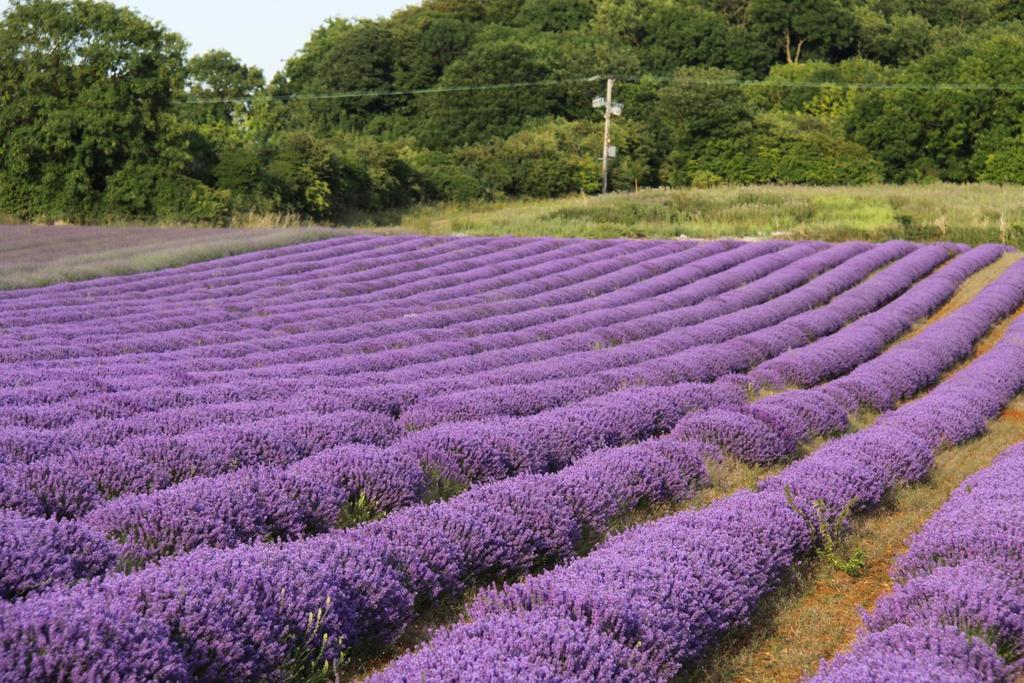In one or two sentences, can you explain what this image depicts? In this image there is a flower field and behind it there are trees and a current pole. 